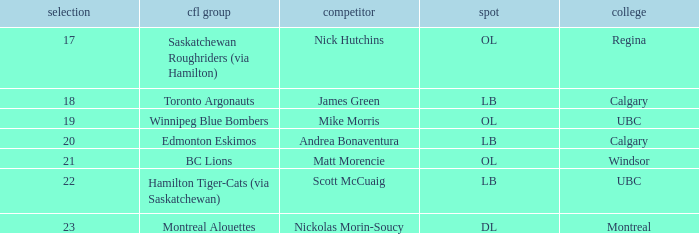What number picks were the players who went to Calgary?  18, 20. 